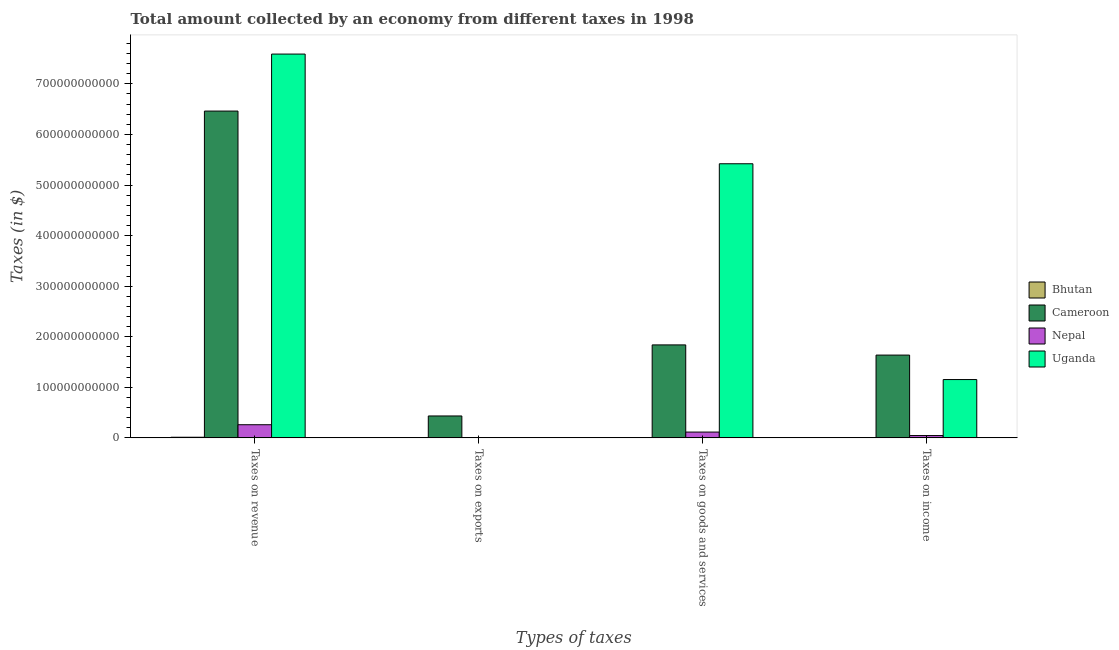How many bars are there on the 3rd tick from the left?
Offer a terse response. 4. How many bars are there on the 2nd tick from the right?
Offer a terse response. 4. What is the label of the 3rd group of bars from the left?
Provide a succinct answer. Taxes on goods and services. What is the amount collected as tax on goods in Nepal?
Your answer should be very brief. 1.15e+1. Across all countries, what is the maximum amount collected as tax on revenue?
Ensure brevity in your answer.  7.59e+11. Across all countries, what is the minimum amount collected as tax on revenue?
Offer a very short reply. 1.25e+09. In which country was the amount collected as tax on exports maximum?
Provide a short and direct response. Cameroon. In which country was the amount collected as tax on income minimum?
Offer a terse response. Bhutan. What is the total amount collected as tax on exports in the graph?
Ensure brevity in your answer.  4.39e+1. What is the difference between the amount collected as tax on goods in Bhutan and that in Uganda?
Offer a very short reply. -5.41e+11. What is the difference between the amount collected as tax on goods in Bhutan and the amount collected as tax on exports in Nepal?
Make the answer very short. 3.02e+08. What is the average amount collected as tax on revenue per country?
Provide a succinct answer. 3.58e+11. What is the difference between the amount collected as tax on revenue and amount collected as tax on goods in Nepal?
Keep it short and to the point. 1.45e+1. In how many countries, is the amount collected as tax on exports greater than 200000000000 $?
Provide a short and direct response. 0. What is the ratio of the amount collected as tax on exports in Uganda to that in Cameroon?
Your answer should be compact. 0.01. Is the amount collected as tax on revenue in Cameroon less than that in Uganda?
Make the answer very short. Yes. Is the difference between the amount collected as tax on revenue in Nepal and Uganda greater than the difference between the amount collected as tax on income in Nepal and Uganda?
Your response must be concise. No. What is the difference between the highest and the second highest amount collected as tax on goods?
Offer a terse response. 3.58e+11. What is the difference between the highest and the lowest amount collected as tax on goods?
Ensure brevity in your answer.  5.41e+11. Is the sum of the amount collected as tax on revenue in Bhutan and Nepal greater than the maximum amount collected as tax on income across all countries?
Make the answer very short. No. What does the 1st bar from the left in Taxes on exports represents?
Your answer should be very brief. Bhutan. What does the 4th bar from the right in Taxes on income represents?
Give a very brief answer. Bhutan. How many bars are there?
Make the answer very short. 16. Are all the bars in the graph horizontal?
Offer a terse response. No. What is the difference between two consecutive major ticks on the Y-axis?
Provide a short and direct response. 1.00e+11. Does the graph contain grids?
Your answer should be compact. No. Where does the legend appear in the graph?
Your answer should be very brief. Center right. What is the title of the graph?
Keep it short and to the point. Total amount collected by an economy from different taxes in 1998. Does "Saudi Arabia" appear as one of the legend labels in the graph?
Your answer should be compact. No. What is the label or title of the X-axis?
Provide a succinct answer. Types of taxes. What is the label or title of the Y-axis?
Your response must be concise. Taxes (in $). What is the Taxes (in $) of Bhutan in Taxes on revenue?
Provide a short and direct response. 1.25e+09. What is the Taxes (in $) in Cameroon in Taxes on revenue?
Provide a short and direct response. 6.46e+11. What is the Taxes (in $) in Nepal in Taxes on revenue?
Your answer should be compact. 2.60e+1. What is the Taxes (in $) in Uganda in Taxes on revenue?
Your answer should be very brief. 7.59e+11. What is the Taxes (in $) of Bhutan in Taxes on exports?
Make the answer very short. 1.85e+07. What is the Taxes (in $) of Cameroon in Taxes on exports?
Make the answer very short. 4.33e+1. What is the Taxes (in $) in Nepal in Taxes on exports?
Keep it short and to the point. 2.17e+08. What is the Taxes (in $) in Uganda in Taxes on exports?
Offer a terse response. 3.00e+08. What is the Taxes (in $) of Bhutan in Taxes on goods and services?
Ensure brevity in your answer.  5.19e+08. What is the Taxes (in $) of Cameroon in Taxes on goods and services?
Ensure brevity in your answer.  1.84e+11. What is the Taxes (in $) of Nepal in Taxes on goods and services?
Make the answer very short. 1.15e+1. What is the Taxes (in $) in Uganda in Taxes on goods and services?
Ensure brevity in your answer.  5.42e+11. What is the Taxes (in $) in Bhutan in Taxes on income?
Provide a short and direct response. 6.68e+08. What is the Taxes (in $) in Cameroon in Taxes on income?
Your answer should be compact. 1.64e+11. What is the Taxes (in $) of Nepal in Taxes on income?
Make the answer very short. 4.58e+09. What is the Taxes (in $) of Uganda in Taxes on income?
Offer a terse response. 1.15e+11. Across all Types of taxes, what is the maximum Taxes (in $) in Bhutan?
Make the answer very short. 1.25e+09. Across all Types of taxes, what is the maximum Taxes (in $) in Cameroon?
Your answer should be very brief. 6.46e+11. Across all Types of taxes, what is the maximum Taxes (in $) in Nepal?
Provide a succinct answer. 2.60e+1. Across all Types of taxes, what is the maximum Taxes (in $) in Uganda?
Ensure brevity in your answer.  7.59e+11. Across all Types of taxes, what is the minimum Taxes (in $) in Bhutan?
Give a very brief answer. 1.85e+07. Across all Types of taxes, what is the minimum Taxes (in $) in Cameroon?
Keep it short and to the point. 4.33e+1. Across all Types of taxes, what is the minimum Taxes (in $) in Nepal?
Give a very brief answer. 2.17e+08. Across all Types of taxes, what is the minimum Taxes (in $) in Uganda?
Ensure brevity in your answer.  3.00e+08. What is the total Taxes (in $) of Bhutan in the graph?
Provide a succinct answer. 2.45e+09. What is the total Taxes (in $) of Cameroon in the graph?
Offer a very short reply. 1.04e+12. What is the total Taxes (in $) of Nepal in the graph?
Your answer should be compact. 4.23e+1. What is the total Taxes (in $) in Uganda in the graph?
Keep it short and to the point. 1.42e+12. What is the difference between the Taxes (in $) in Bhutan in Taxes on revenue and that in Taxes on exports?
Offer a terse response. 1.23e+09. What is the difference between the Taxes (in $) of Cameroon in Taxes on revenue and that in Taxes on exports?
Make the answer very short. 6.03e+11. What is the difference between the Taxes (in $) in Nepal in Taxes on revenue and that in Taxes on exports?
Your answer should be very brief. 2.58e+1. What is the difference between the Taxes (in $) of Uganda in Taxes on revenue and that in Taxes on exports?
Your answer should be very brief. 7.59e+11. What is the difference between the Taxes (in $) of Bhutan in Taxes on revenue and that in Taxes on goods and services?
Offer a very short reply. 7.27e+08. What is the difference between the Taxes (in $) in Cameroon in Taxes on revenue and that in Taxes on goods and services?
Your answer should be compact. 4.62e+11. What is the difference between the Taxes (in $) in Nepal in Taxes on revenue and that in Taxes on goods and services?
Provide a succinct answer. 1.45e+1. What is the difference between the Taxes (in $) in Uganda in Taxes on revenue and that in Taxes on goods and services?
Ensure brevity in your answer.  2.17e+11. What is the difference between the Taxes (in $) in Bhutan in Taxes on revenue and that in Taxes on income?
Keep it short and to the point. 5.79e+08. What is the difference between the Taxes (in $) in Cameroon in Taxes on revenue and that in Taxes on income?
Provide a short and direct response. 4.82e+11. What is the difference between the Taxes (in $) of Nepal in Taxes on revenue and that in Taxes on income?
Your answer should be compact. 2.14e+1. What is the difference between the Taxes (in $) of Uganda in Taxes on revenue and that in Taxes on income?
Offer a terse response. 6.44e+11. What is the difference between the Taxes (in $) of Bhutan in Taxes on exports and that in Taxes on goods and services?
Your answer should be compact. -5.01e+08. What is the difference between the Taxes (in $) of Cameroon in Taxes on exports and that in Taxes on goods and services?
Ensure brevity in your answer.  -1.40e+11. What is the difference between the Taxes (in $) of Nepal in Taxes on exports and that in Taxes on goods and services?
Provide a short and direct response. -1.13e+1. What is the difference between the Taxes (in $) of Uganda in Taxes on exports and that in Taxes on goods and services?
Your response must be concise. -5.42e+11. What is the difference between the Taxes (in $) of Bhutan in Taxes on exports and that in Taxes on income?
Your answer should be compact. -6.49e+08. What is the difference between the Taxes (in $) of Cameroon in Taxes on exports and that in Taxes on income?
Your answer should be compact. -1.20e+11. What is the difference between the Taxes (in $) in Nepal in Taxes on exports and that in Taxes on income?
Make the answer very short. -4.36e+09. What is the difference between the Taxes (in $) in Uganda in Taxes on exports and that in Taxes on income?
Your response must be concise. -1.15e+11. What is the difference between the Taxes (in $) of Bhutan in Taxes on goods and services and that in Taxes on income?
Ensure brevity in your answer.  -1.49e+08. What is the difference between the Taxes (in $) of Cameroon in Taxes on goods and services and that in Taxes on income?
Give a very brief answer. 2.01e+1. What is the difference between the Taxes (in $) of Nepal in Taxes on goods and services and that in Taxes on income?
Your response must be concise. 6.90e+09. What is the difference between the Taxes (in $) in Uganda in Taxes on goods and services and that in Taxes on income?
Offer a terse response. 4.27e+11. What is the difference between the Taxes (in $) of Bhutan in Taxes on revenue and the Taxes (in $) of Cameroon in Taxes on exports?
Give a very brief answer. -4.21e+1. What is the difference between the Taxes (in $) of Bhutan in Taxes on revenue and the Taxes (in $) of Nepal in Taxes on exports?
Your answer should be compact. 1.03e+09. What is the difference between the Taxes (in $) in Bhutan in Taxes on revenue and the Taxes (in $) in Uganda in Taxes on exports?
Offer a very short reply. 9.46e+08. What is the difference between the Taxes (in $) of Cameroon in Taxes on revenue and the Taxes (in $) of Nepal in Taxes on exports?
Your answer should be compact. 6.46e+11. What is the difference between the Taxes (in $) in Cameroon in Taxes on revenue and the Taxes (in $) in Uganda in Taxes on exports?
Provide a short and direct response. 6.46e+11. What is the difference between the Taxes (in $) of Nepal in Taxes on revenue and the Taxes (in $) of Uganda in Taxes on exports?
Ensure brevity in your answer.  2.57e+1. What is the difference between the Taxes (in $) in Bhutan in Taxes on revenue and the Taxes (in $) in Cameroon in Taxes on goods and services?
Provide a succinct answer. -1.83e+11. What is the difference between the Taxes (in $) of Bhutan in Taxes on revenue and the Taxes (in $) of Nepal in Taxes on goods and services?
Your response must be concise. -1.02e+1. What is the difference between the Taxes (in $) in Bhutan in Taxes on revenue and the Taxes (in $) in Uganda in Taxes on goods and services?
Provide a succinct answer. -5.41e+11. What is the difference between the Taxes (in $) in Cameroon in Taxes on revenue and the Taxes (in $) in Nepal in Taxes on goods and services?
Your answer should be compact. 6.35e+11. What is the difference between the Taxes (in $) of Cameroon in Taxes on revenue and the Taxes (in $) of Uganda in Taxes on goods and services?
Give a very brief answer. 1.04e+11. What is the difference between the Taxes (in $) in Nepal in Taxes on revenue and the Taxes (in $) in Uganda in Taxes on goods and services?
Keep it short and to the point. -5.16e+11. What is the difference between the Taxes (in $) in Bhutan in Taxes on revenue and the Taxes (in $) in Cameroon in Taxes on income?
Provide a succinct answer. -1.62e+11. What is the difference between the Taxes (in $) of Bhutan in Taxes on revenue and the Taxes (in $) of Nepal in Taxes on income?
Offer a very short reply. -3.33e+09. What is the difference between the Taxes (in $) in Bhutan in Taxes on revenue and the Taxes (in $) in Uganda in Taxes on income?
Give a very brief answer. -1.14e+11. What is the difference between the Taxes (in $) in Cameroon in Taxes on revenue and the Taxes (in $) in Nepal in Taxes on income?
Offer a very short reply. 6.42e+11. What is the difference between the Taxes (in $) in Cameroon in Taxes on revenue and the Taxes (in $) in Uganda in Taxes on income?
Your answer should be very brief. 5.31e+11. What is the difference between the Taxes (in $) of Nepal in Taxes on revenue and the Taxes (in $) of Uganda in Taxes on income?
Your response must be concise. -8.93e+1. What is the difference between the Taxes (in $) of Bhutan in Taxes on exports and the Taxes (in $) of Cameroon in Taxes on goods and services?
Offer a terse response. -1.84e+11. What is the difference between the Taxes (in $) in Bhutan in Taxes on exports and the Taxes (in $) in Nepal in Taxes on goods and services?
Ensure brevity in your answer.  -1.15e+1. What is the difference between the Taxes (in $) of Bhutan in Taxes on exports and the Taxes (in $) of Uganda in Taxes on goods and services?
Your answer should be compact. -5.42e+11. What is the difference between the Taxes (in $) in Cameroon in Taxes on exports and the Taxes (in $) in Nepal in Taxes on goods and services?
Give a very brief answer. 3.18e+1. What is the difference between the Taxes (in $) of Cameroon in Taxes on exports and the Taxes (in $) of Uganda in Taxes on goods and services?
Give a very brief answer. -4.99e+11. What is the difference between the Taxes (in $) of Nepal in Taxes on exports and the Taxes (in $) of Uganda in Taxes on goods and services?
Make the answer very short. -5.42e+11. What is the difference between the Taxes (in $) in Bhutan in Taxes on exports and the Taxes (in $) in Cameroon in Taxes on income?
Make the answer very short. -1.64e+11. What is the difference between the Taxes (in $) in Bhutan in Taxes on exports and the Taxes (in $) in Nepal in Taxes on income?
Your answer should be compact. -4.56e+09. What is the difference between the Taxes (in $) in Bhutan in Taxes on exports and the Taxes (in $) in Uganda in Taxes on income?
Give a very brief answer. -1.15e+11. What is the difference between the Taxes (in $) of Cameroon in Taxes on exports and the Taxes (in $) of Nepal in Taxes on income?
Make the answer very short. 3.87e+1. What is the difference between the Taxes (in $) in Cameroon in Taxes on exports and the Taxes (in $) in Uganda in Taxes on income?
Keep it short and to the point. -7.20e+1. What is the difference between the Taxes (in $) of Nepal in Taxes on exports and the Taxes (in $) of Uganda in Taxes on income?
Your response must be concise. -1.15e+11. What is the difference between the Taxes (in $) of Bhutan in Taxes on goods and services and the Taxes (in $) of Cameroon in Taxes on income?
Give a very brief answer. -1.63e+11. What is the difference between the Taxes (in $) in Bhutan in Taxes on goods and services and the Taxes (in $) in Nepal in Taxes on income?
Your response must be concise. -4.06e+09. What is the difference between the Taxes (in $) of Bhutan in Taxes on goods and services and the Taxes (in $) of Uganda in Taxes on income?
Your answer should be compact. -1.15e+11. What is the difference between the Taxes (in $) of Cameroon in Taxes on goods and services and the Taxes (in $) of Nepal in Taxes on income?
Make the answer very short. 1.79e+11. What is the difference between the Taxes (in $) in Cameroon in Taxes on goods and services and the Taxes (in $) in Uganda in Taxes on income?
Provide a succinct answer. 6.85e+1. What is the difference between the Taxes (in $) in Nepal in Taxes on goods and services and the Taxes (in $) in Uganda in Taxes on income?
Provide a short and direct response. -1.04e+11. What is the average Taxes (in $) of Bhutan per Types of taxes?
Your answer should be compact. 6.13e+08. What is the average Taxes (in $) of Cameroon per Types of taxes?
Ensure brevity in your answer.  2.59e+11. What is the average Taxes (in $) of Nepal per Types of taxes?
Provide a short and direct response. 1.06e+1. What is the average Taxes (in $) in Uganda per Types of taxes?
Offer a very short reply. 3.54e+11. What is the difference between the Taxes (in $) in Bhutan and Taxes (in $) in Cameroon in Taxes on revenue?
Offer a terse response. -6.45e+11. What is the difference between the Taxes (in $) in Bhutan and Taxes (in $) in Nepal in Taxes on revenue?
Your response must be concise. -2.47e+1. What is the difference between the Taxes (in $) in Bhutan and Taxes (in $) in Uganda in Taxes on revenue?
Your response must be concise. -7.58e+11. What is the difference between the Taxes (in $) in Cameroon and Taxes (in $) in Nepal in Taxes on revenue?
Offer a very short reply. 6.20e+11. What is the difference between the Taxes (in $) of Cameroon and Taxes (in $) of Uganda in Taxes on revenue?
Make the answer very short. -1.13e+11. What is the difference between the Taxes (in $) in Nepal and Taxes (in $) in Uganda in Taxes on revenue?
Make the answer very short. -7.33e+11. What is the difference between the Taxes (in $) of Bhutan and Taxes (in $) of Cameroon in Taxes on exports?
Your answer should be very brief. -4.33e+1. What is the difference between the Taxes (in $) of Bhutan and Taxes (in $) of Nepal in Taxes on exports?
Ensure brevity in your answer.  -1.99e+08. What is the difference between the Taxes (in $) of Bhutan and Taxes (in $) of Uganda in Taxes on exports?
Make the answer very short. -2.82e+08. What is the difference between the Taxes (in $) of Cameroon and Taxes (in $) of Nepal in Taxes on exports?
Your response must be concise. 4.31e+1. What is the difference between the Taxes (in $) of Cameroon and Taxes (in $) of Uganda in Taxes on exports?
Provide a short and direct response. 4.30e+1. What is the difference between the Taxes (in $) of Nepal and Taxes (in $) of Uganda in Taxes on exports?
Provide a short and direct response. -8.30e+07. What is the difference between the Taxes (in $) in Bhutan and Taxes (in $) in Cameroon in Taxes on goods and services?
Ensure brevity in your answer.  -1.83e+11. What is the difference between the Taxes (in $) in Bhutan and Taxes (in $) in Nepal in Taxes on goods and services?
Keep it short and to the point. -1.10e+1. What is the difference between the Taxes (in $) in Bhutan and Taxes (in $) in Uganda in Taxes on goods and services?
Give a very brief answer. -5.41e+11. What is the difference between the Taxes (in $) in Cameroon and Taxes (in $) in Nepal in Taxes on goods and services?
Offer a very short reply. 1.72e+11. What is the difference between the Taxes (in $) of Cameroon and Taxes (in $) of Uganda in Taxes on goods and services?
Keep it short and to the point. -3.58e+11. What is the difference between the Taxes (in $) in Nepal and Taxes (in $) in Uganda in Taxes on goods and services?
Give a very brief answer. -5.31e+11. What is the difference between the Taxes (in $) in Bhutan and Taxes (in $) in Cameroon in Taxes on income?
Your answer should be compact. -1.63e+11. What is the difference between the Taxes (in $) of Bhutan and Taxes (in $) of Nepal in Taxes on income?
Ensure brevity in your answer.  -3.91e+09. What is the difference between the Taxes (in $) of Bhutan and Taxes (in $) of Uganda in Taxes on income?
Provide a short and direct response. -1.15e+11. What is the difference between the Taxes (in $) in Cameroon and Taxes (in $) in Nepal in Taxes on income?
Your response must be concise. 1.59e+11. What is the difference between the Taxes (in $) in Cameroon and Taxes (in $) in Uganda in Taxes on income?
Keep it short and to the point. 4.84e+1. What is the difference between the Taxes (in $) in Nepal and Taxes (in $) in Uganda in Taxes on income?
Provide a short and direct response. -1.11e+11. What is the ratio of the Taxes (in $) in Bhutan in Taxes on revenue to that in Taxes on exports?
Make the answer very short. 67.5. What is the ratio of the Taxes (in $) of Cameroon in Taxes on revenue to that in Taxes on exports?
Offer a terse response. 14.92. What is the ratio of the Taxes (in $) of Nepal in Taxes on revenue to that in Taxes on exports?
Offer a terse response. 119.77. What is the ratio of the Taxes (in $) in Uganda in Taxes on revenue to that in Taxes on exports?
Make the answer very short. 2529.67. What is the ratio of the Taxes (in $) of Bhutan in Taxes on revenue to that in Taxes on goods and services?
Your answer should be compact. 2.4. What is the ratio of the Taxes (in $) of Cameroon in Taxes on revenue to that in Taxes on goods and services?
Offer a very short reply. 3.52. What is the ratio of the Taxes (in $) of Nepal in Taxes on revenue to that in Taxes on goods and services?
Give a very brief answer. 2.26. What is the ratio of the Taxes (in $) of Uganda in Taxes on revenue to that in Taxes on goods and services?
Provide a succinct answer. 1.4. What is the ratio of the Taxes (in $) of Bhutan in Taxes on revenue to that in Taxes on income?
Your response must be concise. 1.87. What is the ratio of the Taxes (in $) of Cameroon in Taxes on revenue to that in Taxes on income?
Keep it short and to the point. 3.95. What is the ratio of the Taxes (in $) in Nepal in Taxes on revenue to that in Taxes on income?
Make the answer very short. 5.68. What is the ratio of the Taxes (in $) in Uganda in Taxes on revenue to that in Taxes on income?
Offer a terse response. 6.58. What is the ratio of the Taxes (in $) in Bhutan in Taxes on exports to that in Taxes on goods and services?
Offer a terse response. 0.04. What is the ratio of the Taxes (in $) in Cameroon in Taxes on exports to that in Taxes on goods and services?
Make the answer very short. 0.24. What is the ratio of the Taxes (in $) in Nepal in Taxes on exports to that in Taxes on goods and services?
Offer a very short reply. 0.02. What is the ratio of the Taxes (in $) in Uganda in Taxes on exports to that in Taxes on goods and services?
Your answer should be very brief. 0. What is the ratio of the Taxes (in $) in Bhutan in Taxes on exports to that in Taxes on income?
Your response must be concise. 0.03. What is the ratio of the Taxes (in $) in Cameroon in Taxes on exports to that in Taxes on income?
Provide a short and direct response. 0.26. What is the ratio of the Taxes (in $) of Nepal in Taxes on exports to that in Taxes on income?
Provide a succinct answer. 0.05. What is the ratio of the Taxes (in $) in Uganda in Taxes on exports to that in Taxes on income?
Provide a succinct answer. 0. What is the ratio of the Taxes (in $) in Bhutan in Taxes on goods and services to that in Taxes on income?
Ensure brevity in your answer.  0.78. What is the ratio of the Taxes (in $) of Cameroon in Taxes on goods and services to that in Taxes on income?
Offer a terse response. 1.12. What is the ratio of the Taxes (in $) in Nepal in Taxes on goods and services to that in Taxes on income?
Offer a very short reply. 2.51. What is the ratio of the Taxes (in $) of Uganda in Taxes on goods and services to that in Taxes on income?
Provide a succinct answer. 4.7. What is the difference between the highest and the second highest Taxes (in $) in Bhutan?
Your answer should be compact. 5.79e+08. What is the difference between the highest and the second highest Taxes (in $) in Cameroon?
Your answer should be very brief. 4.62e+11. What is the difference between the highest and the second highest Taxes (in $) in Nepal?
Your answer should be compact. 1.45e+1. What is the difference between the highest and the second highest Taxes (in $) in Uganda?
Your answer should be very brief. 2.17e+11. What is the difference between the highest and the lowest Taxes (in $) of Bhutan?
Your response must be concise. 1.23e+09. What is the difference between the highest and the lowest Taxes (in $) of Cameroon?
Offer a terse response. 6.03e+11. What is the difference between the highest and the lowest Taxes (in $) of Nepal?
Give a very brief answer. 2.58e+1. What is the difference between the highest and the lowest Taxes (in $) in Uganda?
Make the answer very short. 7.59e+11. 